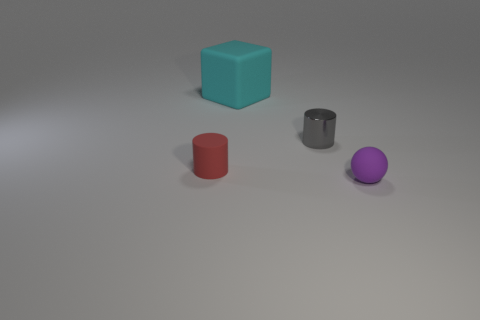Add 3 cyan cubes. How many objects exist? 7 Subtract all cubes. How many objects are left? 3 Add 2 small red matte objects. How many small red matte objects are left? 3 Add 1 yellow metallic spheres. How many yellow metallic spheres exist? 1 Subtract 0 gray blocks. How many objects are left? 4 Subtract all gray shiny things. Subtract all blue rubber cylinders. How many objects are left? 3 